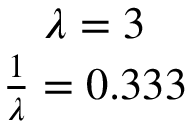<formula> <loc_0><loc_0><loc_500><loc_500>\begin{array} { c } { \lambda = 3 } \\ { \frac { 1 } { \lambda } = 0 . 3 3 3 } \end{array}</formula> 